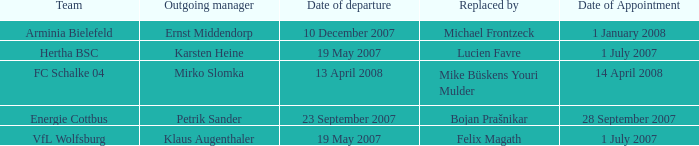When is the appointment date for outgoing manager Petrik Sander? 28 September 2007. 